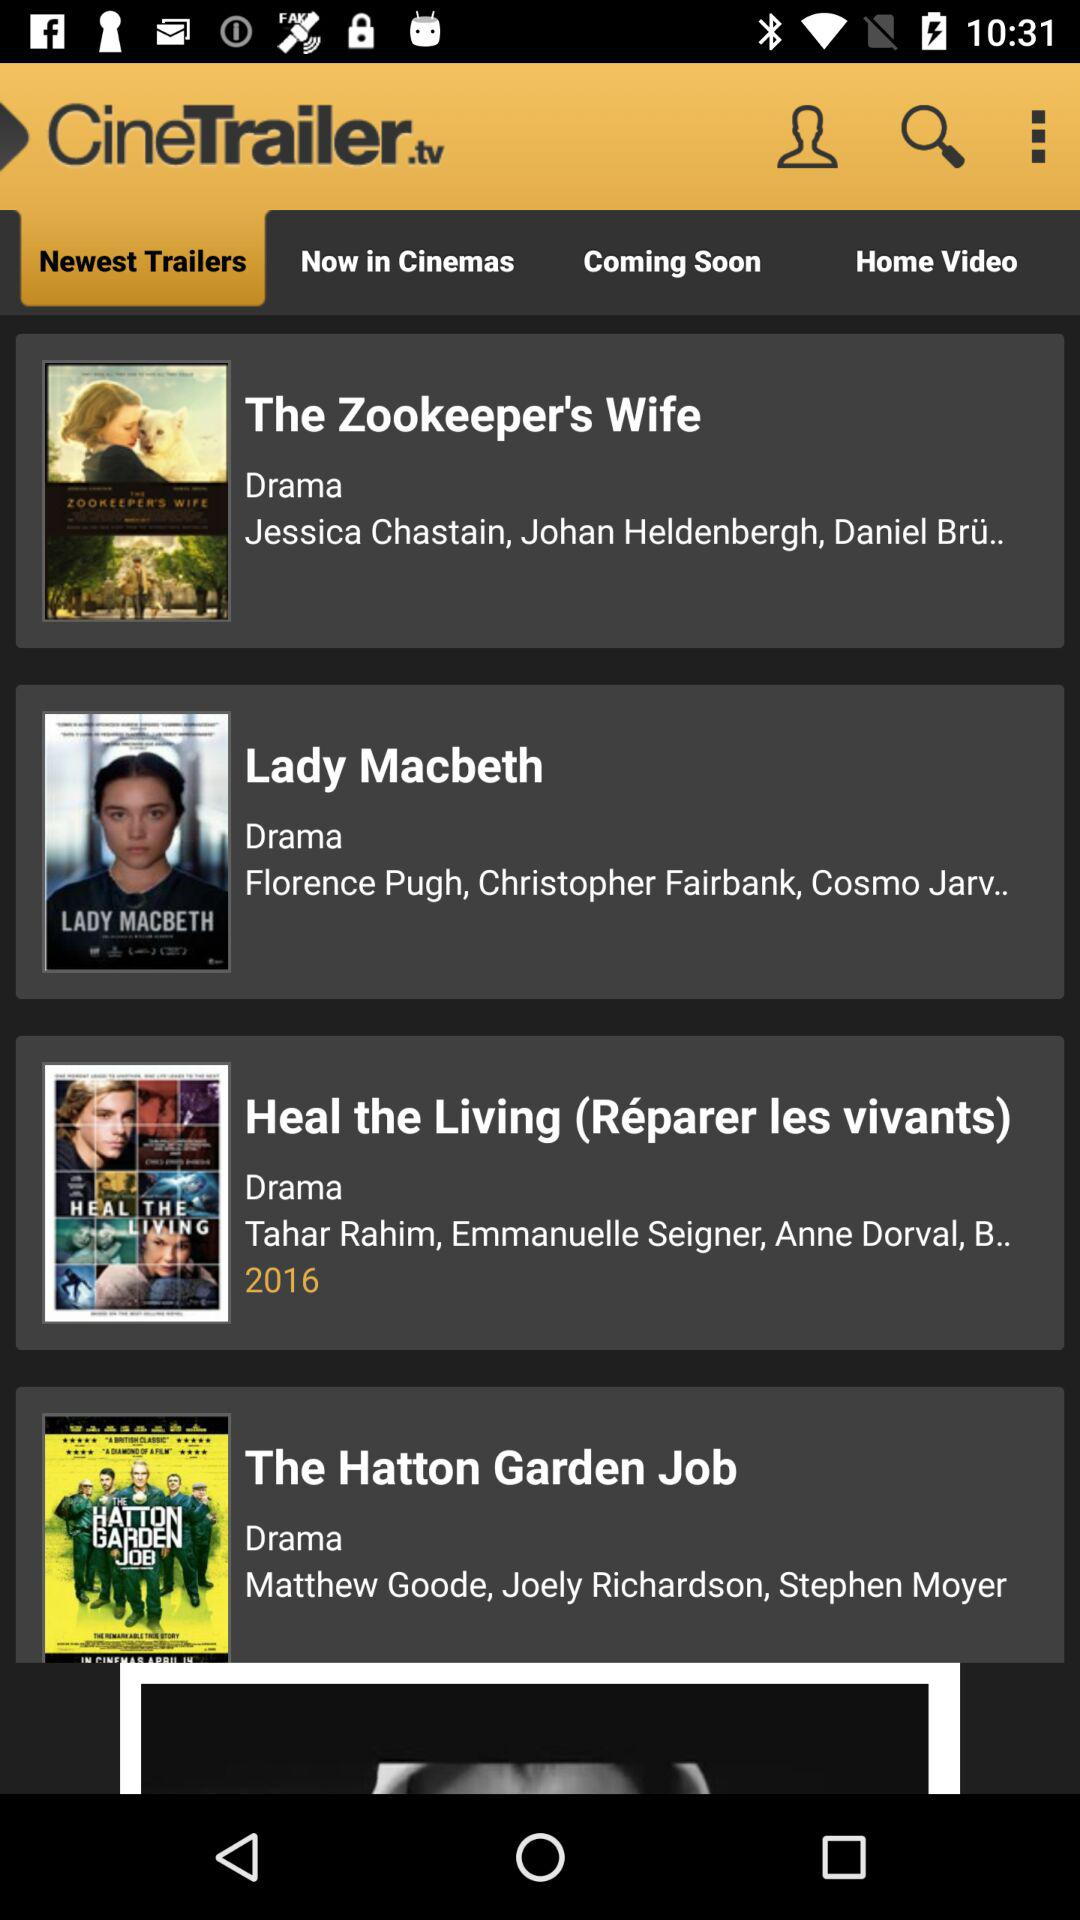When was "Heal the Living" released? It was released in 2016. 